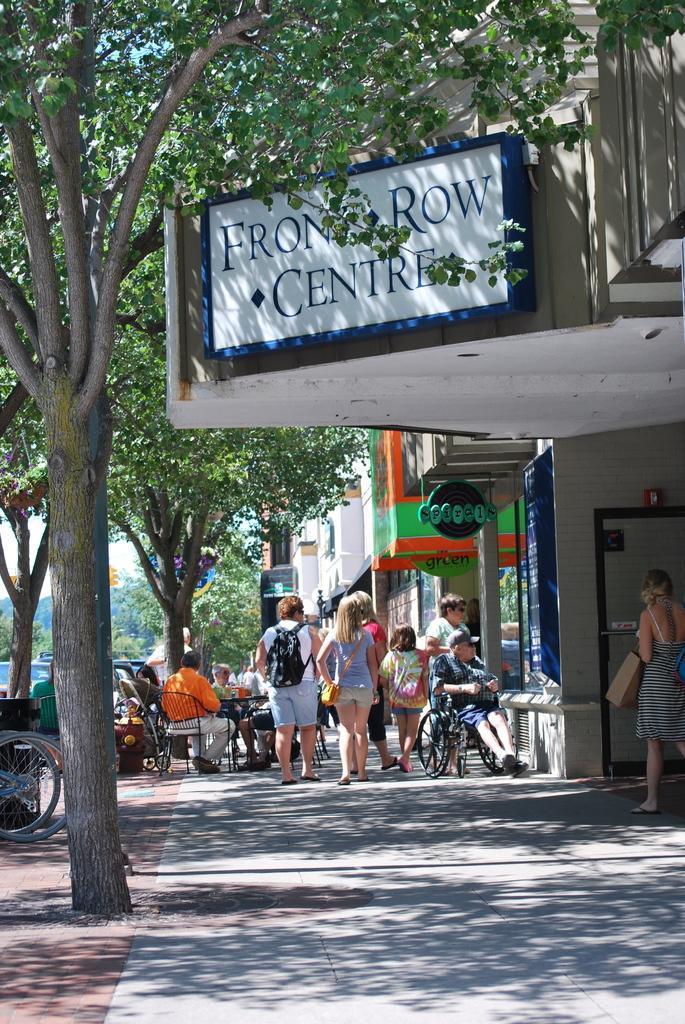How would you summarize this image in a sentence or two? In this image we can see a few people, some of them are sitting on the chairs, one person is sitting on the wheel chair, there are bicycles, vehicles, trees, there are boards with text on them, also we can see buildings, and the sky. 